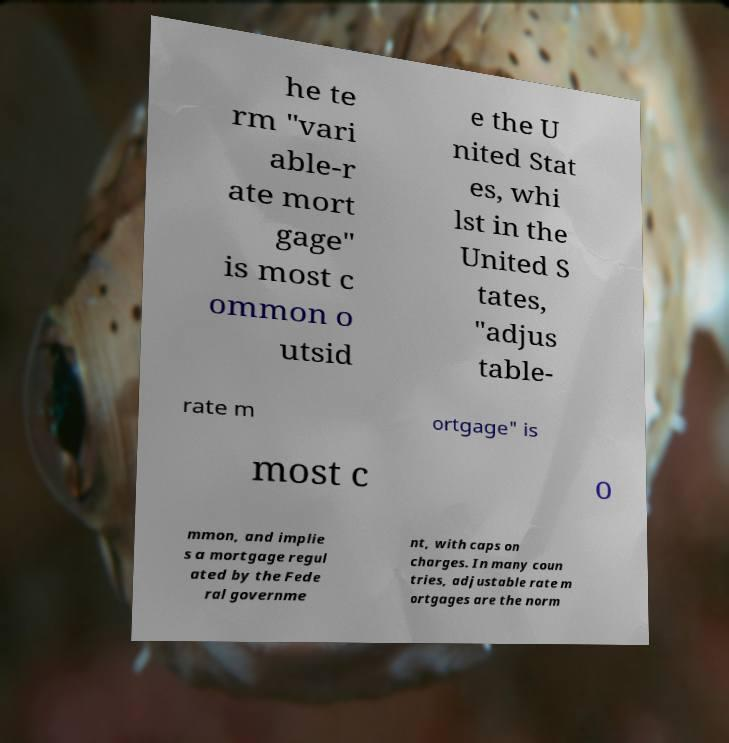Can you accurately transcribe the text from the provided image for me? he te rm "vari able-r ate mort gage" is most c ommon o utsid e the U nited Stat es, whi lst in the United S tates, "adjus table- rate m ortgage" is most c o mmon, and implie s a mortgage regul ated by the Fede ral governme nt, with caps on charges. In many coun tries, adjustable rate m ortgages are the norm 